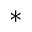<formula> <loc_0><loc_0><loc_500><loc_500>^ { * }</formula> 